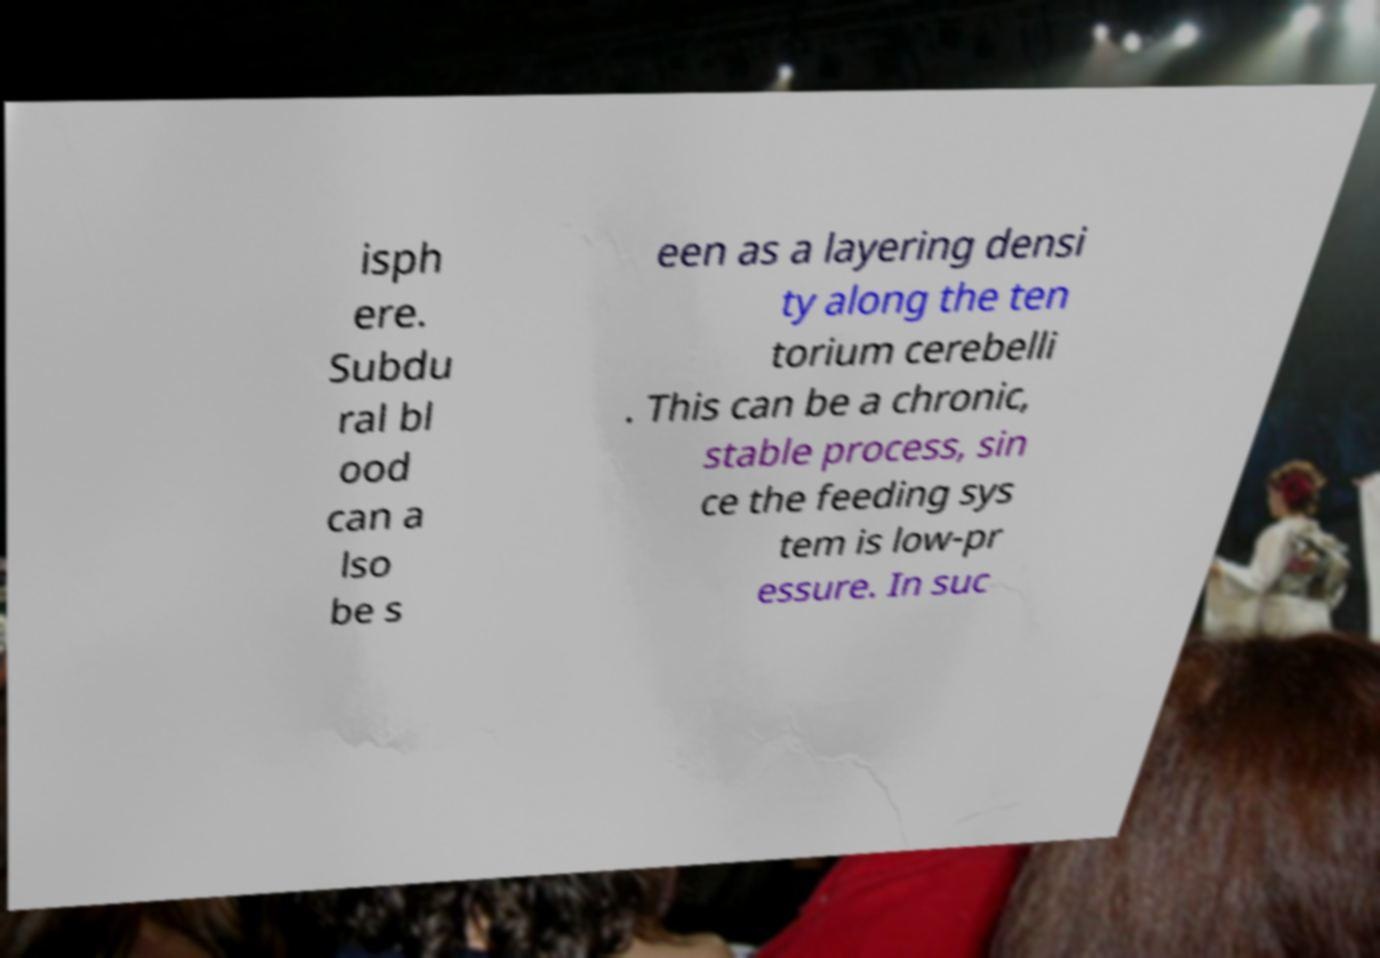Can you read and provide the text displayed in the image?This photo seems to have some interesting text. Can you extract and type it out for me? isph ere. Subdu ral bl ood can a lso be s een as a layering densi ty along the ten torium cerebelli . This can be a chronic, stable process, sin ce the feeding sys tem is low-pr essure. In suc 